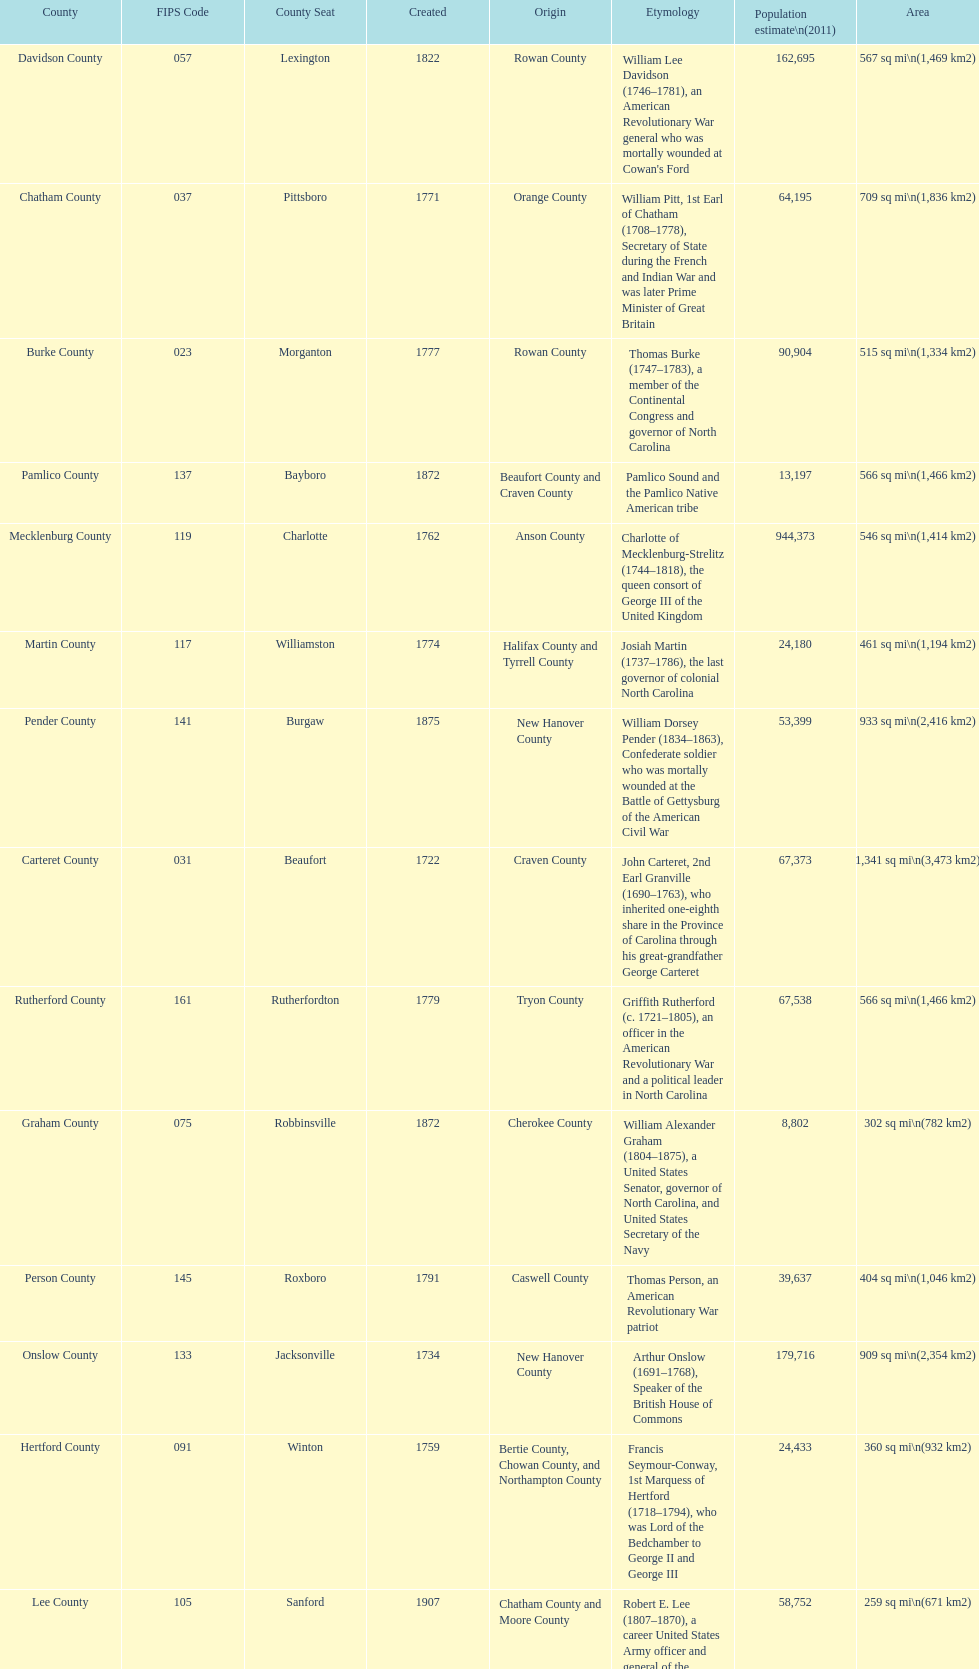Which county covers the most area? Dare County. 